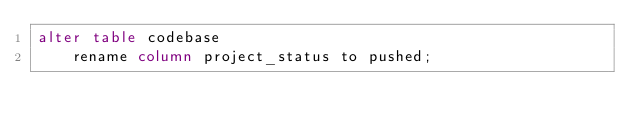<code> <loc_0><loc_0><loc_500><loc_500><_SQL_>alter table codebase
    rename column project_status to pushed;</code> 